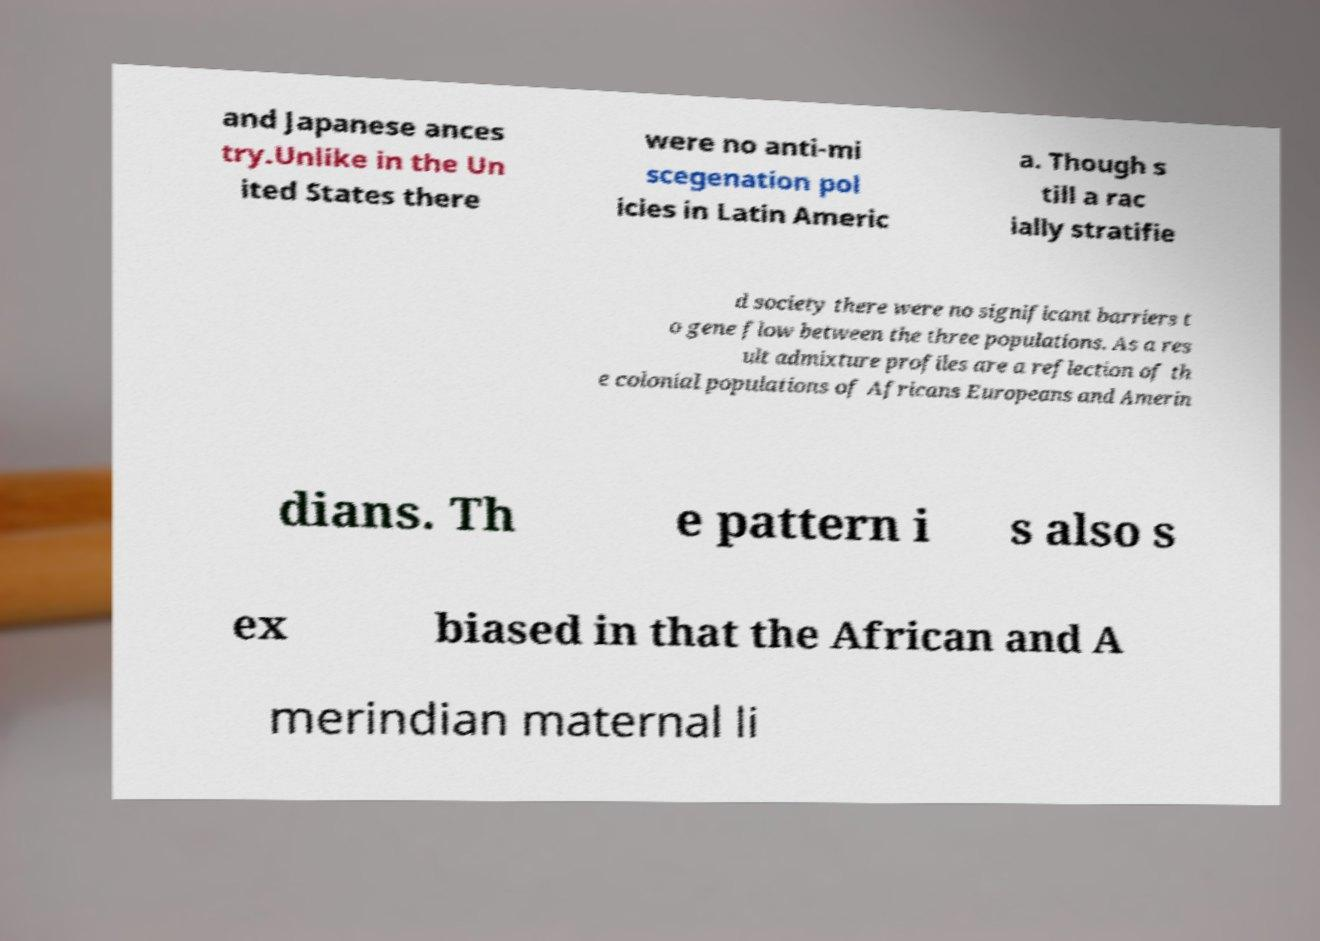Can you read and provide the text displayed in the image?This photo seems to have some interesting text. Can you extract and type it out for me? and Japanese ances try.Unlike in the Un ited States there were no anti-mi scegenation pol icies in Latin Americ a. Though s till a rac ially stratifie d society there were no significant barriers t o gene flow between the three populations. As a res ult admixture profiles are a reflection of th e colonial populations of Africans Europeans and Amerin dians. Th e pattern i s also s ex biased in that the African and A merindian maternal li 